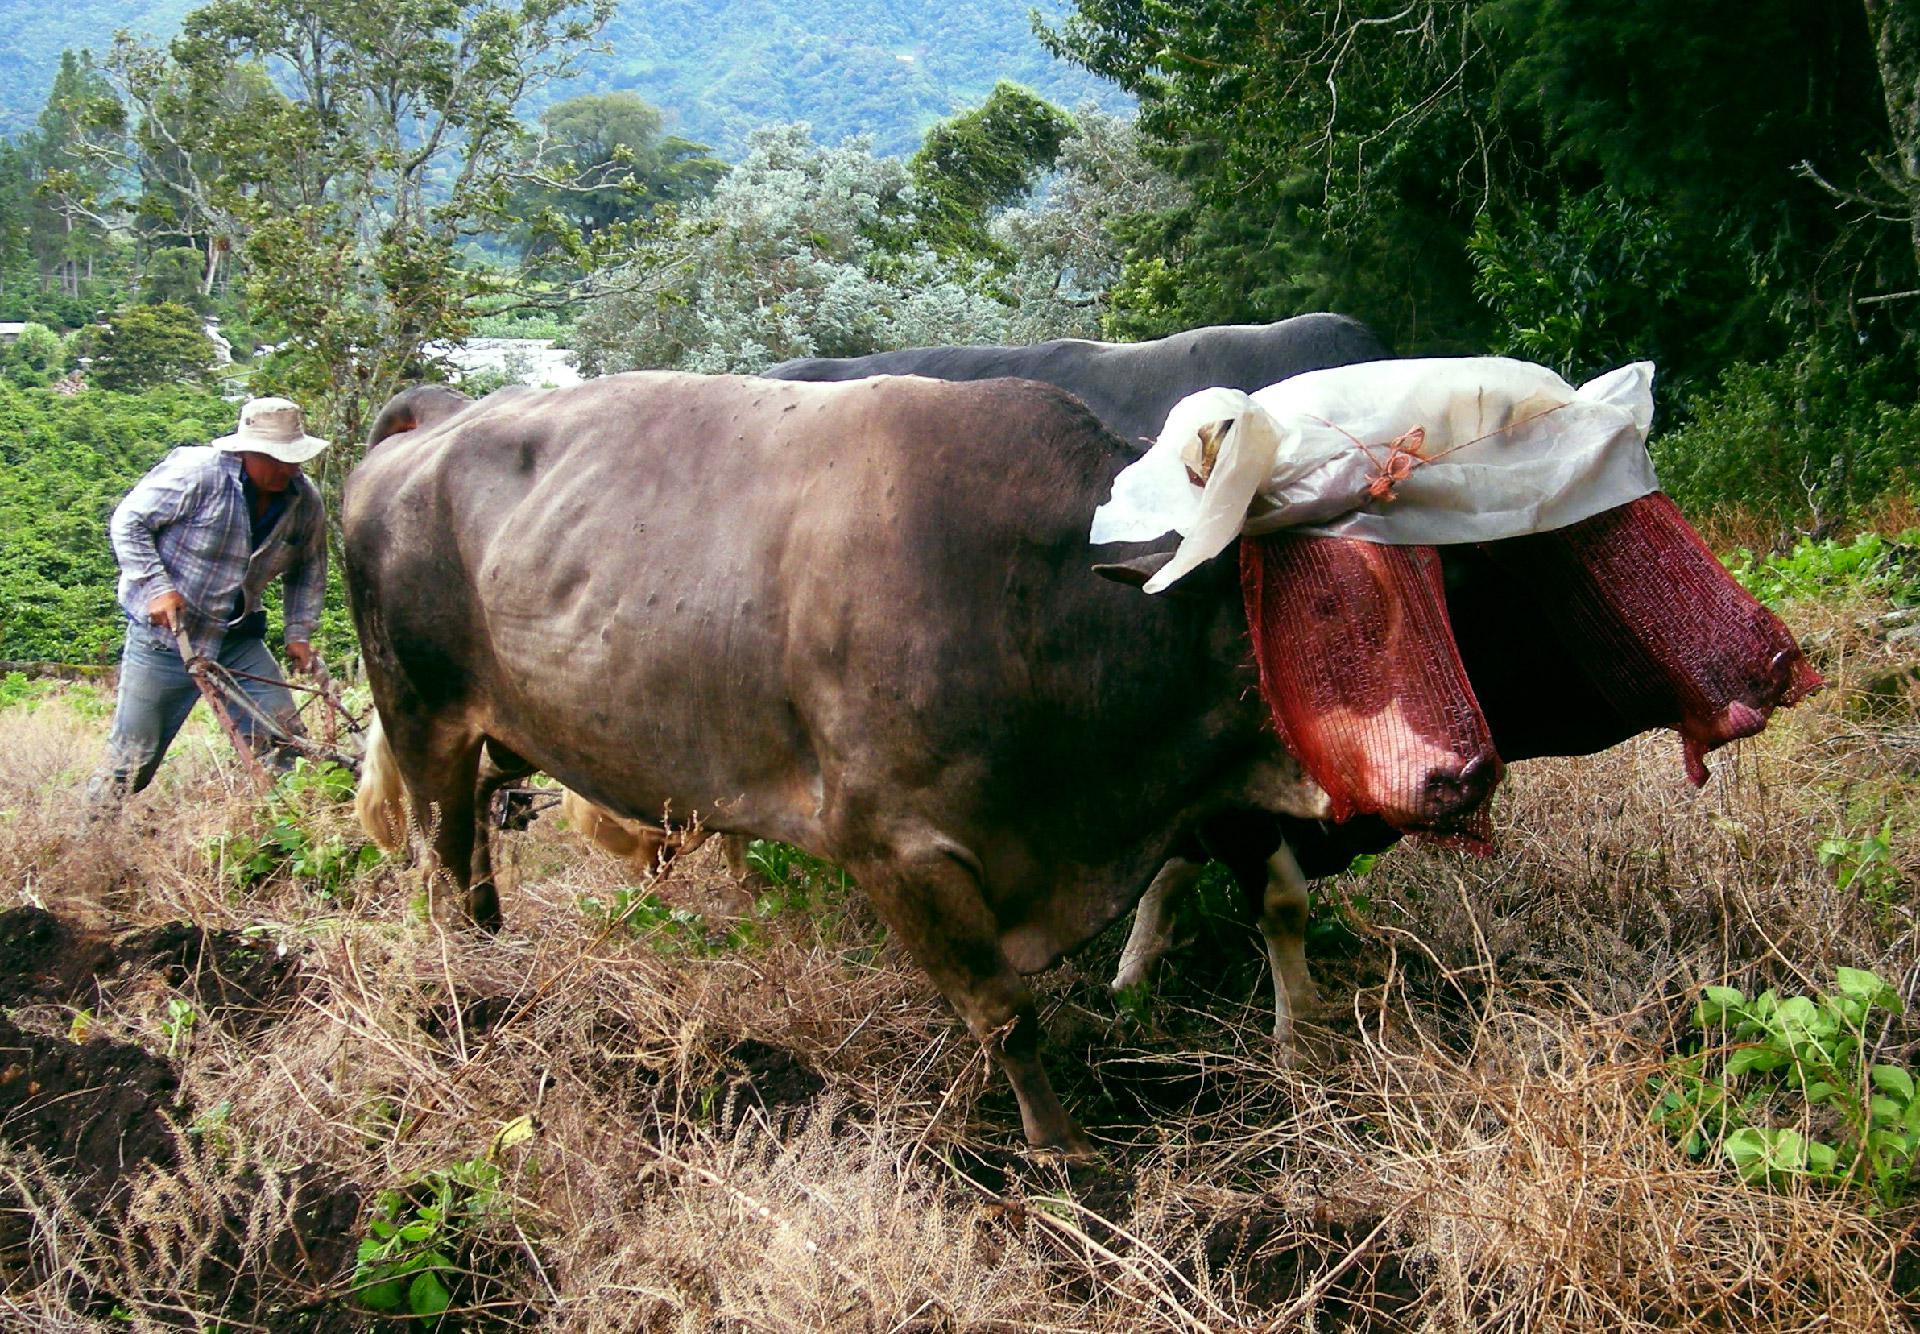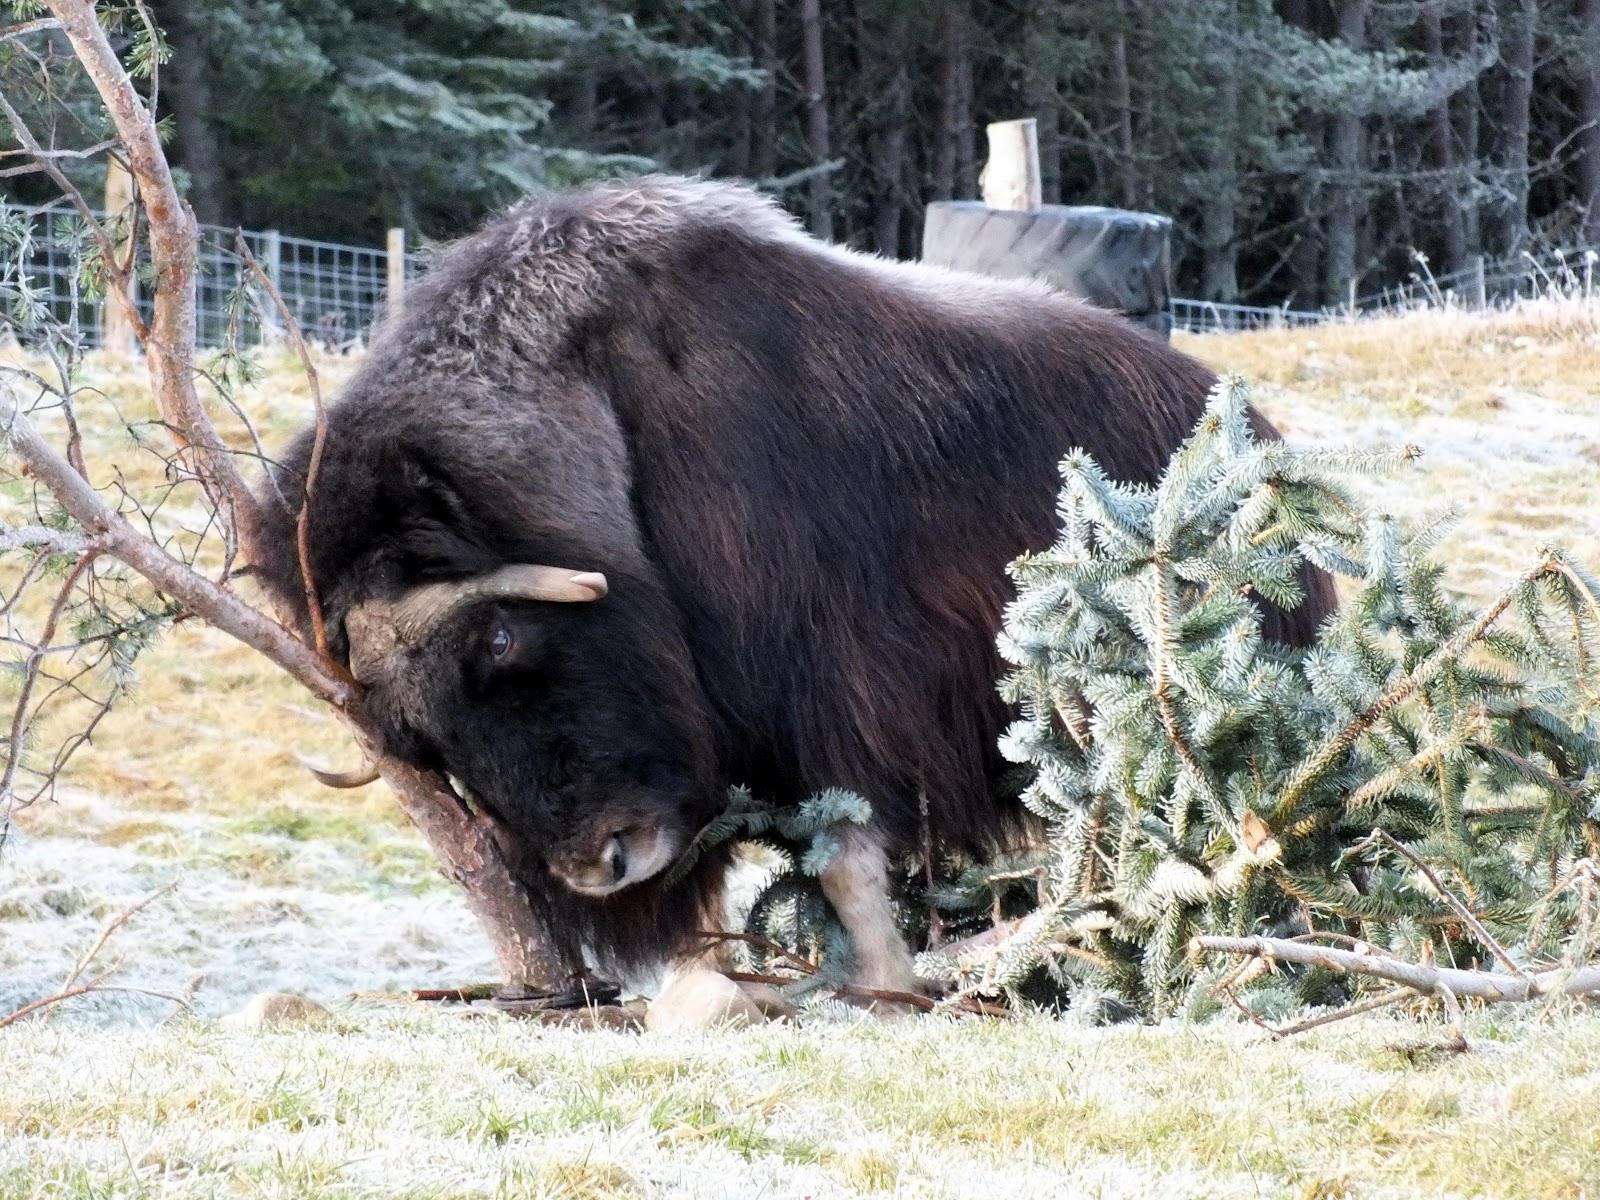The first image is the image on the left, the second image is the image on the right. For the images shown, is this caption "The left image shows a man walking behind a pair of cattle attached to a farming implement ." true? Answer yes or no. Yes. The first image is the image on the left, the second image is the image on the right. Analyze the images presented: Is the assertion "One man steering a plow is behind two oxen pulling the plow." valid? Answer yes or no. Yes. 